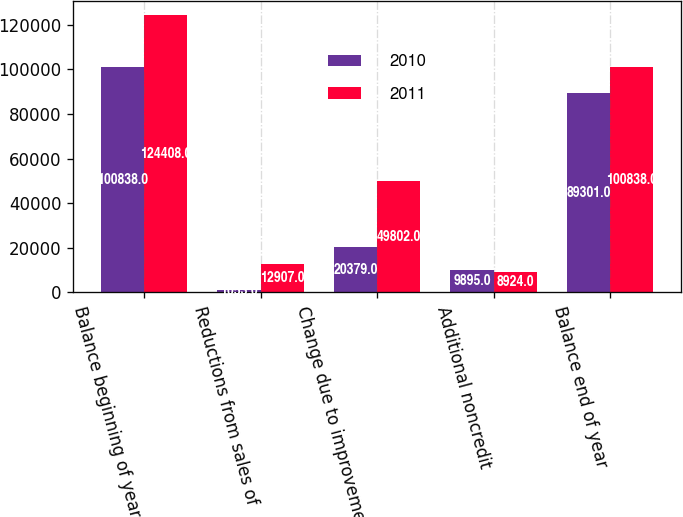Convert chart. <chart><loc_0><loc_0><loc_500><loc_500><stacked_bar_chart><ecel><fcel>Balance beginning of year<fcel>Reductions from sales of<fcel>Change due to improvement in<fcel>Additional noncredit<fcel>Balance end of year<nl><fcel>2010<fcel>100838<fcel>1053<fcel>20379<fcel>9895<fcel>89301<nl><fcel>2011<fcel>124408<fcel>12907<fcel>49802<fcel>8924<fcel>100838<nl></chart> 